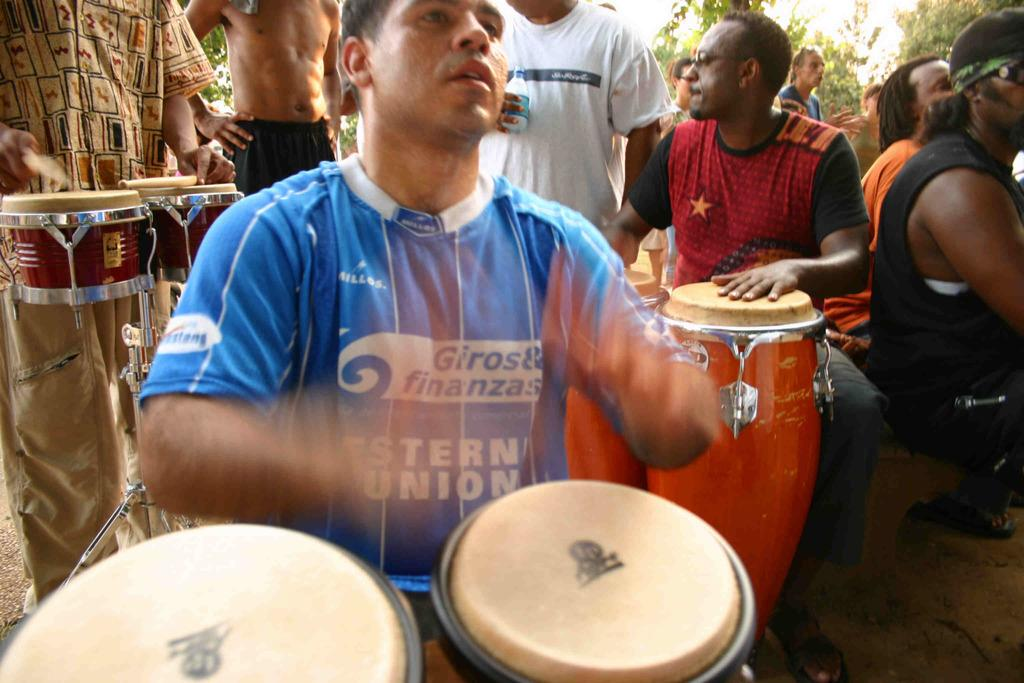What are the people in the image doing? In the image, there are persons standing and sitting, and three persons are playing musical instruments. Can you describe the actions of the people playing musical instruments? The three persons playing musical instruments are actively playing their respective instruments. What can be seen in the background of the image? There are trees visible in the background of the image. Where is the snail located in the image? There is no snail present in the image. What direction does the cobweb point to in the image? There is no cobweb present in the image. 